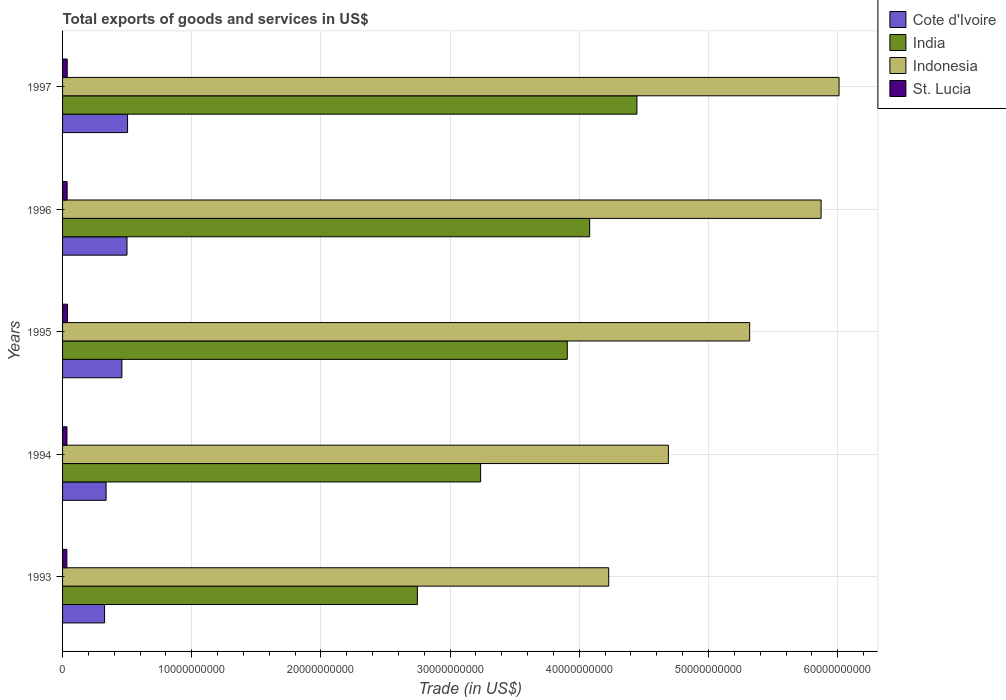How many different coloured bars are there?
Offer a very short reply. 4. How many groups of bars are there?
Ensure brevity in your answer.  5. Are the number of bars per tick equal to the number of legend labels?
Keep it short and to the point. Yes. Are the number of bars on each tick of the Y-axis equal?
Your answer should be compact. Yes. How many bars are there on the 5th tick from the top?
Provide a short and direct response. 4. In how many cases, is the number of bars for a given year not equal to the number of legend labels?
Offer a very short reply. 0. What is the total exports of goods and services in Cote d'Ivoire in 1994?
Offer a very short reply. 3.37e+09. Across all years, what is the maximum total exports of goods and services in Cote d'Ivoire?
Give a very brief answer. 5.03e+09. Across all years, what is the minimum total exports of goods and services in St. Lucia?
Give a very brief answer. 3.33e+08. In which year was the total exports of goods and services in Cote d'Ivoire maximum?
Your answer should be compact. 1997. What is the total total exports of goods and services in Indonesia in the graph?
Ensure brevity in your answer.  2.61e+11. What is the difference between the total exports of goods and services in St. Lucia in 1993 and that in 1996?
Offer a terse response. -2.02e+07. What is the difference between the total exports of goods and services in India in 1994 and the total exports of goods and services in Indonesia in 1997?
Give a very brief answer. -2.77e+1. What is the average total exports of goods and services in India per year?
Provide a succinct answer. 3.68e+1. In the year 1994, what is the difference between the total exports of goods and services in India and total exports of goods and services in Cote d'Ivoire?
Offer a very short reply. 2.90e+1. What is the ratio of the total exports of goods and services in St. Lucia in 1993 to that in 1996?
Keep it short and to the point. 0.94. Is the total exports of goods and services in St. Lucia in 1993 less than that in 1995?
Ensure brevity in your answer.  Yes. What is the difference between the highest and the second highest total exports of goods and services in Cote d'Ivoire?
Your response must be concise. 4.13e+07. What is the difference between the highest and the lowest total exports of goods and services in Cote d'Ivoire?
Make the answer very short. 1.78e+09. What does the 4th bar from the top in 1996 represents?
Offer a very short reply. Cote d'Ivoire. What does the 1st bar from the bottom in 1993 represents?
Provide a succinct answer. Cote d'Ivoire. Is it the case that in every year, the sum of the total exports of goods and services in St. Lucia and total exports of goods and services in Indonesia is greater than the total exports of goods and services in Cote d'Ivoire?
Ensure brevity in your answer.  Yes. Are all the bars in the graph horizontal?
Offer a terse response. Yes. How many years are there in the graph?
Ensure brevity in your answer.  5. Are the values on the major ticks of X-axis written in scientific E-notation?
Your answer should be compact. No. Does the graph contain any zero values?
Give a very brief answer. No. Does the graph contain grids?
Your answer should be very brief. Yes. Where does the legend appear in the graph?
Make the answer very short. Top right. What is the title of the graph?
Make the answer very short. Total exports of goods and services in US$. What is the label or title of the X-axis?
Provide a succinct answer. Trade (in US$). What is the label or title of the Y-axis?
Make the answer very short. Years. What is the Trade (in US$) of Cote d'Ivoire in 1993?
Your answer should be very brief. 3.25e+09. What is the Trade (in US$) of India in 1993?
Offer a terse response. 2.75e+1. What is the Trade (in US$) of Indonesia in 1993?
Offer a very short reply. 4.23e+1. What is the Trade (in US$) of St. Lucia in 1993?
Provide a succinct answer. 3.33e+08. What is the Trade (in US$) in Cote d'Ivoire in 1994?
Give a very brief answer. 3.37e+09. What is the Trade (in US$) in India in 1994?
Offer a terse response. 3.24e+1. What is the Trade (in US$) in Indonesia in 1994?
Keep it short and to the point. 4.69e+1. What is the Trade (in US$) of St. Lucia in 1994?
Provide a short and direct response. 3.40e+08. What is the Trade (in US$) in Cote d'Ivoire in 1995?
Give a very brief answer. 4.59e+09. What is the Trade (in US$) in India in 1995?
Provide a succinct answer. 3.91e+1. What is the Trade (in US$) of Indonesia in 1995?
Ensure brevity in your answer.  5.32e+1. What is the Trade (in US$) of St. Lucia in 1995?
Give a very brief answer. 3.79e+08. What is the Trade (in US$) in Cote d'Ivoire in 1996?
Your answer should be very brief. 4.99e+09. What is the Trade (in US$) in India in 1996?
Keep it short and to the point. 4.08e+1. What is the Trade (in US$) of Indonesia in 1996?
Your answer should be very brief. 5.87e+1. What is the Trade (in US$) of St. Lucia in 1996?
Offer a terse response. 3.53e+08. What is the Trade (in US$) of Cote d'Ivoire in 1997?
Give a very brief answer. 5.03e+09. What is the Trade (in US$) of India in 1997?
Provide a short and direct response. 4.45e+1. What is the Trade (in US$) in Indonesia in 1997?
Your response must be concise. 6.01e+1. What is the Trade (in US$) of St. Lucia in 1997?
Your response must be concise. 3.59e+08. Across all years, what is the maximum Trade (in US$) of Cote d'Ivoire?
Ensure brevity in your answer.  5.03e+09. Across all years, what is the maximum Trade (in US$) in India?
Keep it short and to the point. 4.45e+1. Across all years, what is the maximum Trade (in US$) of Indonesia?
Make the answer very short. 6.01e+1. Across all years, what is the maximum Trade (in US$) of St. Lucia?
Your response must be concise. 3.79e+08. Across all years, what is the minimum Trade (in US$) in Cote d'Ivoire?
Make the answer very short. 3.25e+09. Across all years, what is the minimum Trade (in US$) in India?
Provide a short and direct response. 2.75e+1. Across all years, what is the minimum Trade (in US$) in Indonesia?
Make the answer very short. 4.23e+1. Across all years, what is the minimum Trade (in US$) of St. Lucia?
Make the answer very short. 3.33e+08. What is the total Trade (in US$) in Cote d'Ivoire in the graph?
Your answer should be compact. 2.12e+1. What is the total Trade (in US$) in India in the graph?
Your response must be concise. 1.84e+11. What is the total Trade (in US$) in Indonesia in the graph?
Your answer should be very brief. 2.61e+11. What is the total Trade (in US$) in St. Lucia in the graph?
Your response must be concise. 1.76e+09. What is the difference between the Trade (in US$) in Cote d'Ivoire in 1993 and that in 1994?
Your answer should be compact. -1.17e+08. What is the difference between the Trade (in US$) in India in 1993 and that in 1994?
Ensure brevity in your answer.  -4.89e+09. What is the difference between the Trade (in US$) of Indonesia in 1993 and that in 1994?
Your response must be concise. -4.62e+09. What is the difference between the Trade (in US$) in St. Lucia in 1993 and that in 1994?
Provide a short and direct response. -7.10e+06. What is the difference between the Trade (in US$) in Cote d'Ivoire in 1993 and that in 1995?
Ensure brevity in your answer.  -1.34e+09. What is the difference between the Trade (in US$) in India in 1993 and that in 1995?
Ensure brevity in your answer.  -1.16e+1. What is the difference between the Trade (in US$) in Indonesia in 1993 and that in 1995?
Provide a short and direct response. -1.09e+1. What is the difference between the Trade (in US$) of St. Lucia in 1993 and that in 1995?
Make the answer very short. -4.59e+07. What is the difference between the Trade (in US$) of Cote d'Ivoire in 1993 and that in 1996?
Your answer should be compact. -1.74e+09. What is the difference between the Trade (in US$) in India in 1993 and that in 1996?
Your response must be concise. -1.33e+1. What is the difference between the Trade (in US$) in Indonesia in 1993 and that in 1996?
Provide a short and direct response. -1.64e+1. What is the difference between the Trade (in US$) in St. Lucia in 1993 and that in 1996?
Provide a short and direct response. -2.02e+07. What is the difference between the Trade (in US$) in Cote d'Ivoire in 1993 and that in 1997?
Ensure brevity in your answer.  -1.78e+09. What is the difference between the Trade (in US$) of India in 1993 and that in 1997?
Give a very brief answer. -1.70e+1. What is the difference between the Trade (in US$) in Indonesia in 1993 and that in 1997?
Make the answer very short. -1.78e+1. What is the difference between the Trade (in US$) in St. Lucia in 1993 and that in 1997?
Provide a short and direct response. -2.58e+07. What is the difference between the Trade (in US$) of Cote d'Ivoire in 1994 and that in 1995?
Your answer should be very brief. -1.22e+09. What is the difference between the Trade (in US$) of India in 1994 and that in 1995?
Keep it short and to the point. -6.71e+09. What is the difference between the Trade (in US$) in Indonesia in 1994 and that in 1995?
Offer a terse response. -6.29e+09. What is the difference between the Trade (in US$) in St. Lucia in 1994 and that in 1995?
Give a very brief answer. -3.88e+07. What is the difference between the Trade (in US$) in Cote d'Ivoire in 1994 and that in 1996?
Provide a succinct answer. -1.62e+09. What is the difference between the Trade (in US$) in India in 1994 and that in 1996?
Offer a very short reply. -8.44e+09. What is the difference between the Trade (in US$) of Indonesia in 1994 and that in 1996?
Keep it short and to the point. -1.18e+1. What is the difference between the Trade (in US$) of St. Lucia in 1994 and that in 1996?
Ensure brevity in your answer.  -1.31e+07. What is the difference between the Trade (in US$) in Cote d'Ivoire in 1994 and that in 1997?
Make the answer very short. -1.66e+09. What is the difference between the Trade (in US$) of India in 1994 and that in 1997?
Your response must be concise. -1.21e+1. What is the difference between the Trade (in US$) in Indonesia in 1994 and that in 1997?
Keep it short and to the point. -1.32e+1. What is the difference between the Trade (in US$) of St. Lucia in 1994 and that in 1997?
Provide a succinct answer. -1.87e+07. What is the difference between the Trade (in US$) of Cote d'Ivoire in 1995 and that in 1996?
Ensure brevity in your answer.  -3.96e+08. What is the difference between the Trade (in US$) in India in 1995 and that in 1996?
Your response must be concise. -1.73e+09. What is the difference between the Trade (in US$) in Indonesia in 1995 and that in 1996?
Offer a terse response. -5.53e+09. What is the difference between the Trade (in US$) in St. Lucia in 1995 and that in 1996?
Your answer should be compact. 2.57e+07. What is the difference between the Trade (in US$) in Cote d'Ivoire in 1995 and that in 1997?
Keep it short and to the point. -4.37e+08. What is the difference between the Trade (in US$) in India in 1995 and that in 1997?
Your answer should be very brief. -5.39e+09. What is the difference between the Trade (in US$) of Indonesia in 1995 and that in 1997?
Ensure brevity in your answer.  -6.92e+09. What is the difference between the Trade (in US$) of St. Lucia in 1995 and that in 1997?
Provide a short and direct response. 2.01e+07. What is the difference between the Trade (in US$) of Cote d'Ivoire in 1996 and that in 1997?
Your answer should be compact. -4.13e+07. What is the difference between the Trade (in US$) in India in 1996 and that in 1997?
Your answer should be very brief. -3.66e+09. What is the difference between the Trade (in US$) in Indonesia in 1996 and that in 1997?
Your answer should be very brief. -1.39e+09. What is the difference between the Trade (in US$) of St. Lucia in 1996 and that in 1997?
Offer a very short reply. -5.56e+06. What is the difference between the Trade (in US$) of Cote d'Ivoire in 1993 and the Trade (in US$) of India in 1994?
Offer a very short reply. -2.91e+1. What is the difference between the Trade (in US$) in Cote d'Ivoire in 1993 and the Trade (in US$) in Indonesia in 1994?
Offer a very short reply. -4.36e+1. What is the difference between the Trade (in US$) in Cote d'Ivoire in 1993 and the Trade (in US$) in St. Lucia in 1994?
Your answer should be compact. 2.91e+09. What is the difference between the Trade (in US$) in India in 1993 and the Trade (in US$) in Indonesia in 1994?
Make the answer very short. -1.94e+1. What is the difference between the Trade (in US$) in India in 1993 and the Trade (in US$) in St. Lucia in 1994?
Give a very brief answer. 2.71e+1. What is the difference between the Trade (in US$) in Indonesia in 1993 and the Trade (in US$) in St. Lucia in 1994?
Your answer should be very brief. 4.19e+1. What is the difference between the Trade (in US$) of Cote d'Ivoire in 1993 and the Trade (in US$) of India in 1995?
Make the answer very short. -3.58e+1. What is the difference between the Trade (in US$) in Cote d'Ivoire in 1993 and the Trade (in US$) in Indonesia in 1995?
Your response must be concise. -4.99e+1. What is the difference between the Trade (in US$) in Cote d'Ivoire in 1993 and the Trade (in US$) in St. Lucia in 1995?
Keep it short and to the point. 2.87e+09. What is the difference between the Trade (in US$) in India in 1993 and the Trade (in US$) in Indonesia in 1995?
Your response must be concise. -2.57e+1. What is the difference between the Trade (in US$) of India in 1993 and the Trade (in US$) of St. Lucia in 1995?
Provide a short and direct response. 2.71e+1. What is the difference between the Trade (in US$) of Indonesia in 1993 and the Trade (in US$) of St. Lucia in 1995?
Provide a succinct answer. 4.19e+1. What is the difference between the Trade (in US$) in Cote d'Ivoire in 1993 and the Trade (in US$) in India in 1996?
Offer a terse response. -3.76e+1. What is the difference between the Trade (in US$) in Cote d'Ivoire in 1993 and the Trade (in US$) in Indonesia in 1996?
Your response must be concise. -5.55e+1. What is the difference between the Trade (in US$) of Cote d'Ivoire in 1993 and the Trade (in US$) of St. Lucia in 1996?
Your answer should be compact. 2.90e+09. What is the difference between the Trade (in US$) in India in 1993 and the Trade (in US$) in Indonesia in 1996?
Offer a terse response. -3.13e+1. What is the difference between the Trade (in US$) of India in 1993 and the Trade (in US$) of St. Lucia in 1996?
Your answer should be very brief. 2.71e+1. What is the difference between the Trade (in US$) in Indonesia in 1993 and the Trade (in US$) in St. Lucia in 1996?
Give a very brief answer. 4.19e+1. What is the difference between the Trade (in US$) of Cote d'Ivoire in 1993 and the Trade (in US$) of India in 1997?
Provide a short and direct response. -4.12e+1. What is the difference between the Trade (in US$) in Cote d'Ivoire in 1993 and the Trade (in US$) in Indonesia in 1997?
Ensure brevity in your answer.  -5.69e+1. What is the difference between the Trade (in US$) of Cote d'Ivoire in 1993 and the Trade (in US$) of St. Lucia in 1997?
Provide a succinct answer. 2.89e+09. What is the difference between the Trade (in US$) in India in 1993 and the Trade (in US$) in Indonesia in 1997?
Offer a terse response. -3.26e+1. What is the difference between the Trade (in US$) of India in 1993 and the Trade (in US$) of St. Lucia in 1997?
Your response must be concise. 2.71e+1. What is the difference between the Trade (in US$) in Indonesia in 1993 and the Trade (in US$) in St. Lucia in 1997?
Keep it short and to the point. 4.19e+1. What is the difference between the Trade (in US$) of Cote d'Ivoire in 1994 and the Trade (in US$) of India in 1995?
Provide a short and direct response. -3.57e+1. What is the difference between the Trade (in US$) in Cote d'Ivoire in 1994 and the Trade (in US$) in Indonesia in 1995?
Provide a succinct answer. -4.98e+1. What is the difference between the Trade (in US$) of Cote d'Ivoire in 1994 and the Trade (in US$) of St. Lucia in 1995?
Keep it short and to the point. 2.99e+09. What is the difference between the Trade (in US$) of India in 1994 and the Trade (in US$) of Indonesia in 1995?
Offer a terse response. -2.08e+1. What is the difference between the Trade (in US$) in India in 1994 and the Trade (in US$) in St. Lucia in 1995?
Keep it short and to the point. 3.20e+1. What is the difference between the Trade (in US$) of Indonesia in 1994 and the Trade (in US$) of St. Lucia in 1995?
Keep it short and to the point. 4.65e+1. What is the difference between the Trade (in US$) in Cote d'Ivoire in 1994 and the Trade (in US$) in India in 1996?
Give a very brief answer. -3.74e+1. What is the difference between the Trade (in US$) of Cote d'Ivoire in 1994 and the Trade (in US$) of Indonesia in 1996?
Your answer should be very brief. -5.53e+1. What is the difference between the Trade (in US$) in Cote d'Ivoire in 1994 and the Trade (in US$) in St. Lucia in 1996?
Give a very brief answer. 3.02e+09. What is the difference between the Trade (in US$) in India in 1994 and the Trade (in US$) in Indonesia in 1996?
Offer a terse response. -2.64e+1. What is the difference between the Trade (in US$) in India in 1994 and the Trade (in US$) in St. Lucia in 1996?
Your answer should be very brief. 3.20e+1. What is the difference between the Trade (in US$) in Indonesia in 1994 and the Trade (in US$) in St. Lucia in 1996?
Your answer should be compact. 4.65e+1. What is the difference between the Trade (in US$) in Cote d'Ivoire in 1994 and the Trade (in US$) in India in 1997?
Offer a terse response. -4.11e+1. What is the difference between the Trade (in US$) in Cote d'Ivoire in 1994 and the Trade (in US$) in Indonesia in 1997?
Give a very brief answer. -5.67e+1. What is the difference between the Trade (in US$) in Cote d'Ivoire in 1994 and the Trade (in US$) in St. Lucia in 1997?
Your answer should be very brief. 3.01e+09. What is the difference between the Trade (in US$) of India in 1994 and the Trade (in US$) of Indonesia in 1997?
Offer a terse response. -2.77e+1. What is the difference between the Trade (in US$) of India in 1994 and the Trade (in US$) of St. Lucia in 1997?
Make the answer very short. 3.20e+1. What is the difference between the Trade (in US$) in Indonesia in 1994 and the Trade (in US$) in St. Lucia in 1997?
Keep it short and to the point. 4.65e+1. What is the difference between the Trade (in US$) in Cote d'Ivoire in 1995 and the Trade (in US$) in India in 1996?
Make the answer very short. -3.62e+1. What is the difference between the Trade (in US$) of Cote d'Ivoire in 1995 and the Trade (in US$) of Indonesia in 1996?
Ensure brevity in your answer.  -5.41e+1. What is the difference between the Trade (in US$) in Cote d'Ivoire in 1995 and the Trade (in US$) in St. Lucia in 1996?
Provide a succinct answer. 4.24e+09. What is the difference between the Trade (in US$) in India in 1995 and the Trade (in US$) in Indonesia in 1996?
Ensure brevity in your answer.  -1.96e+1. What is the difference between the Trade (in US$) in India in 1995 and the Trade (in US$) in St. Lucia in 1996?
Ensure brevity in your answer.  3.87e+1. What is the difference between the Trade (in US$) in Indonesia in 1995 and the Trade (in US$) in St. Lucia in 1996?
Provide a short and direct response. 5.28e+1. What is the difference between the Trade (in US$) of Cote d'Ivoire in 1995 and the Trade (in US$) of India in 1997?
Your answer should be very brief. -3.99e+1. What is the difference between the Trade (in US$) in Cote d'Ivoire in 1995 and the Trade (in US$) in Indonesia in 1997?
Give a very brief answer. -5.55e+1. What is the difference between the Trade (in US$) of Cote d'Ivoire in 1995 and the Trade (in US$) of St. Lucia in 1997?
Provide a short and direct response. 4.23e+09. What is the difference between the Trade (in US$) in India in 1995 and the Trade (in US$) in Indonesia in 1997?
Provide a short and direct response. -2.10e+1. What is the difference between the Trade (in US$) of India in 1995 and the Trade (in US$) of St. Lucia in 1997?
Provide a succinct answer. 3.87e+1. What is the difference between the Trade (in US$) of Indonesia in 1995 and the Trade (in US$) of St. Lucia in 1997?
Give a very brief answer. 5.28e+1. What is the difference between the Trade (in US$) of Cote d'Ivoire in 1996 and the Trade (in US$) of India in 1997?
Offer a terse response. -3.95e+1. What is the difference between the Trade (in US$) in Cote d'Ivoire in 1996 and the Trade (in US$) in Indonesia in 1997?
Offer a very short reply. -5.51e+1. What is the difference between the Trade (in US$) in Cote d'Ivoire in 1996 and the Trade (in US$) in St. Lucia in 1997?
Ensure brevity in your answer.  4.63e+09. What is the difference between the Trade (in US$) of India in 1996 and the Trade (in US$) of Indonesia in 1997?
Your answer should be compact. -1.93e+1. What is the difference between the Trade (in US$) in India in 1996 and the Trade (in US$) in St. Lucia in 1997?
Ensure brevity in your answer.  4.04e+1. What is the difference between the Trade (in US$) of Indonesia in 1996 and the Trade (in US$) of St. Lucia in 1997?
Your answer should be very brief. 5.84e+1. What is the average Trade (in US$) in Cote d'Ivoire per year?
Provide a succinct answer. 4.25e+09. What is the average Trade (in US$) in India per year?
Make the answer very short. 3.68e+1. What is the average Trade (in US$) in Indonesia per year?
Ensure brevity in your answer.  5.22e+1. What is the average Trade (in US$) of St. Lucia per year?
Give a very brief answer. 3.53e+08. In the year 1993, what is the difference between the Trade (in US$) of Cote d'Ivoire and Trade (in US$) of India?
Your answer should be very brief. -2.42e+1. In the year 1993, what is the difference between the Trade (in US$) of Cote d'Ivoire and Trade (in US$) of Indonesia?
Your answer should be compact. -3.90e+1. In the year 1993, what is the difference between the Trade (in US$) of Cote d'Ivoire and Trade (in US$) of St. Lucia?
Offer a terse response. 2.92e+09. In the year 1993, what is the difference between the Trade (in US$) of India and Trade (in US$) of Indonesia?
Keep it short and to the point. -1.48e+1. In the year 1993, what is the difference between the Trade (in US$) in India and Trade (in US$) in St. Lucia?
Ensure brevity in your answer.  2.71e+1. In the year 1993, what is the difference between the Trade (in US$) of Indonesia and Trade (in US$) of St. Lucia?
Your response must be concise. 4.19e+1. In the year 1994, what is the difference between the Trade (in US$) in Cote d'Ivoire and Trade (in US$) in India?
Provide a succinct answer. -2.90e+1. In the year 1994, what is the difference between the Trade (in US$) in Cote d'Ivoire and Trade (in US$) in Indonesia?
Provide a succinct answer. -4.35e+1. In the year 1994, what is the difference between the Trade (in US$) of Cote d'Ivoire and Trade (in US$) of St. Lucia?
Make the answer very short. 3.03e+09. In the year 1994, what is the difference between the Trade (in US$) in India and Trade (in US$) in Indonesia?
Make the answer very short. -1.45e+1. In the year 1994, what is the difference between the Trade (in US$) of India and Trade (in US$) of St. Lucia?
Your answer should be compact. 3.20e+1. In the year 1994, what is the difference between the Trade (in US$) in Indonesia and Trade (in US$) in St. Lucia?
Offer a terse response. 4.66e+1. In the year 1995, what is the difference between the Trade (in US$) of Cote d'Ivoire and Trade (in US$) of India?
Your answer should be very brief. -3.45e+1. In the year 1995, what is the difference between the Trade (in US$) in Cote d'Ivoire and Trade (in US$) in Indonesia?
Your response must be concise. -4.86e+1. In the year 1995, what is the difference between the Trade (in US$) of Cote d'Ivoire and Trade (in US$) of St. Lucia?
Provide a short and direct response. 4.21e+09. In the year 1995, what is the difference between the Trade (in US$) in India and Trade (in US$) in Indonesia?
Your answer should be compact. -1.41e+1. In the year 1995, what is the difference between the Trade (in US$) in India and Trade (in US$) in St. Lucia?
Provide a succinct answer. 3.87e+1. In the year 1995, what is the difference between the Trade (in US$) in Indonesia and Trade (in US$) in St. Lucia?
Give a very brief answer. 5.28e+1. In the year 1996, what is the difference between the Trade (in US$) in Cote d'Ivoire and Trade (in US$) in India?
Offer a very short reply. -3.58e+1. In the year 1996, what is the difference between the Trade (in US$) of Cote d'Ivoire and Trade (in US$) of Indonesia?
Keep it short and to the point. -5.37e+1. In the year 1996, what is the difference between the Trade (in US$) in Cote d'Ivoire and Trade (in US$) in St. Lucia?
Your answer should be very brief. 4.64e+09. In the year 1996, what is the difference between the Trade (in US$) of India and Trade (in US$) of Indonesia?
Offer a terse response. -1.79e+1. In the year 1996, what is the difference between the Trade (in US$) of India and Trade (in US$) of St. Lucia?
Keep it short and to the point. 4.04e+1. In the year 1996, what is the difference between the Trade (in US$) in Indonesia and Trade (in US$) in St. Lucia?
Your response must be concise. 5.84e+1. In the year 1997, what is the difference between the Trade (in US$) of Cote d'Ivoire and Trade (in US$) of India?
Keep it short and to the point. -3.94e+1. In the year 1997, what is the difference between the Trade (in US$) of Cote d'Ivoire and Trade (in US$) of Indonesia?
Your response must be concise. -5.51e+1. In the year 1997, what is the difference between the Trade (in US$) of Cote d'Ivoire and Trade (in US$) of St. Lucia?
Give a very brief answer. 4.67e+09. In the year 1997, what is the difference between the Trade (in US$) of India and Trade (in US$) of Indonesia?
Ensure brevity in your answer.  -1.56e+1. In the year 1997, what is the difference between the Trade (in US$) in India and Trade (in US$) in St. Lucia?
Offer a very short reply. 4.41e+1. In the year 1997, what is the difference between the Trade (in US$) of Indonesia and Trade (in US$) of St. Lucia?
Ensure brevity in your answer.  5.97e+1. What is the ratio of the Trade (in US$) in Cote d'Ivoire in 1993 to that in 1994?
Provide a short and direct response. 0.97. What is the ratio of the Trade (in US$) of India in 1993 to that in 1994?
Your answer should be compact. 0.85. What is the ratio of the Trade (in US$) of Indonesia in 1993 to that in 1994?
Your answer should be compact. 0.9. What is the ratio of the Trade (in US$) of St. Lucia in 1993 to that in 1994?
Give a very brief answer. 0.98. What is the ratio of the Trade (in US$) in Cote d'Ivoire in 1993 to that in 1995?
Your response must be concise. 0.71. What is the ratio of the Trade (in US$) in India in 1993 to that in 1995?
Keep it short and to the point. 0.7. What is the ratio of the Trade (in US$) of Indonesia in 1993 to that in 1995?
Provide a succinct answer. 0.79. What is the ratio of the Trade (in US$) in St. Lucia in 1993 to that in 1995?
Your answer should be very brief. 0.88. What is the ratio of the Trade (in US$) of Cote d'Ivoire in 1993 to that in 1996?
Ensure brevity in your answer.  0.65. What is the ratio of the Trade (in US$) in India in 1993 to that in 1996?
Offer a terse response. 0.67. What is the ratio of the Trade (in US$) in Indonesia in 1993 to that in 1996?
Provide a succinct answer. 0.72. What is the ratio of the Trade (in US$) of St. Lucia in 1993 to that in 1996?
Ensure brevity in your answer.  0.94. What is the ratio of the Trade (in US$) of Cote d'Ivoire in 1993 to that in 1997?
Keep it short and to the point. 0.65. What is the ratio of the Trade (in US$) of India in 1993 to that in 1997?
Provide a short and direct response. 0.62. What is the ratio of the Trade (in US$) in Indonesia in 1993 to that in 1997?
Make the answer very short. 0.7. What is the ratio of the Trade (in US$) in St. Lucia in 1993 to that in 1997?
Make the answer very short. 0.93. What is the ratio of the Trade (in US$) of Cote d'Ivoire in 1994 to that in 1995?
Offer a very short reply. 0.73. What is the ratio of the Trade (in US$) of India in 1994 to that in 1995?
Give a very brief answer. 0.83. What is the ratio of the Trade (in US$) of Indonesia in 1994 to that in 1995?
Your response must be concise. 0.88. What is the ratio of the Trade (in US$) of St. Lucia in 1994 to that in 1995?
Offer a very short reply. 0.9. What is the ratio of the Trade (in US$) of Cote d'Ivoire in 1994 to that in 1996?
Your answer should be compact. 0.68. What is the ratio of the Trade (in US$) in India in 1994 to that in 1996?
Make the answer very short. 0.79. What is the ratio of the Trade (in US$) of Indonesia in 1994 to that in 1996?
Make the answer very short. 0.8. What is the ratio of the Trade (in US$) of St. Lucia in 1994 to that in 1996?
Your response must be concise. 0.96. What is the ratio of the Trade (in US$) in Cote d'Ivoire in 1994 to that in 1997?
Your response must be concise. 0.67. What is the ratio of the Trade (in US$) of India in 1994 to that in 1997?
Your answer should be very brief. 0.73. What is the ratio of the Trade (in US$) of Indonesia in 1994 to that in 1997?
Your response must be concise. 0.78. What is the ratio of the Trade (in US$) in St. Lucia in 1994 to that in 1997?
Ensure brevity in your answer.  0.95. What is the ratio of the Trade (in US$) of Cote d'Ivoire in 1995 to that in 1996?
Offer a very short reply. 0.92. What is the ratio of the Trade (in US$) in India in 1995 to that in 1996?
Make the answer very short. 0.96. What is the ratio of the Trade (in US$) in Indonesia in 1995 to that in 1996?
Offer a very short reply. 0.91. What is the ratio of the Trade (in US$) of St. Lucia in 1995 to that in 1996?
Provide a short and direct response. 1.07. What is the ratio of the Trade (in US$) in Cote d'Ivoire in 1995 to that in 1997?
Ensure brevity in your answer.  0.91. What is the ratio of the Trade (in US$) of India in 1995 to that in 1997?
Provide a succinct answer. 0.88. What is the ratio of the Trade (in US$) in Indonesia in 1995 to that in 1997?
Provide a short and direct response. 0.88. What is the ratio of the Trade (in US$) of St. Lucia in 1995 to that in 1997?
Keep it short and to the point. 1.06. What is the ratio of the Trade (in US$) in Cote d'Ivoire in 1996 to that in 1997?
Provide a short and direct response. 0.99. What is the ratio of the Trade (in US$) in India in 1996 to that in 1997?
Offer a terse response. 0.92. What is the ratio of the Trade (in US$) in Indonesia in 1996 to that in 1997?
Your answer should be compact. 0.98. What is the ratio of the Trade (in US$) of St. Lucia in 1996 to that in 1997?
Make the answer very short. 0.98. What is the difference between the highest and the second highest Trade (in US$) in Cote d'Ivoire?
Keep it short and to the point. 4.13e+07. What is the difference between the highest and the second highest Trade (in US$) of India?
Keep it short and to the point. 3.66e+09. What is the difference between the highest and the second highest Trade (in US$) of Indonesia?
Offer a terse response. 1.39e+09. What is the difference between the highest and the second highest Trade (in US$) in St. Lucia?
Ensure brevity in your answer.  2.01e+07. What is the difference between the highest and the lowest Trade (in US$) of Cote d'Ivoire?
Your response must be concise. 1.78e+09. What is the difference between the highest and the lowest Trade (in US$) of India?
Offer a very short reply. 1.70e+1. What is the difference between the highest and the lowest Trade (in US$) in Indonesia?
Give a very brief answer. 1.78e+1. What is the difference between the highest and the lowest Trade (in US$) of St. Lucia?
Your response must be concise. 4.59e+07. 